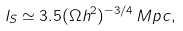<formula> <loc_0><loc_0><loc_500><loc_500>l _ { S } \simeq 3 . 5 ( \Omega h ^ { 2 } ) ^ { - 3 / 4 } \, M p c ,</formula> 